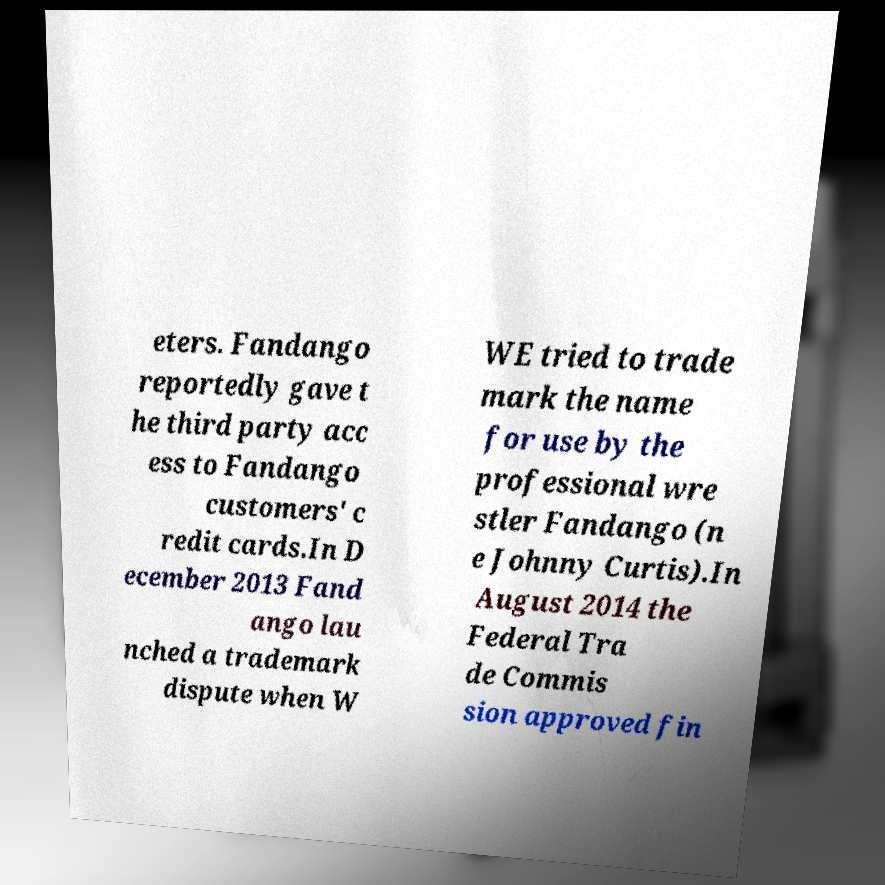Could you extract and type out the text from this image? eters. Fandango reportedly gave t he third party acc ess to Fandango customers' c redit cards.In D ecember 2013 Fand ango lau nched a trademark dispute when W WE tried to trade mark the name for use by the professional wre stler Fandango (n e Johnny Curtis).In August 2014 the Federal Tra de Commis sion approved fin 